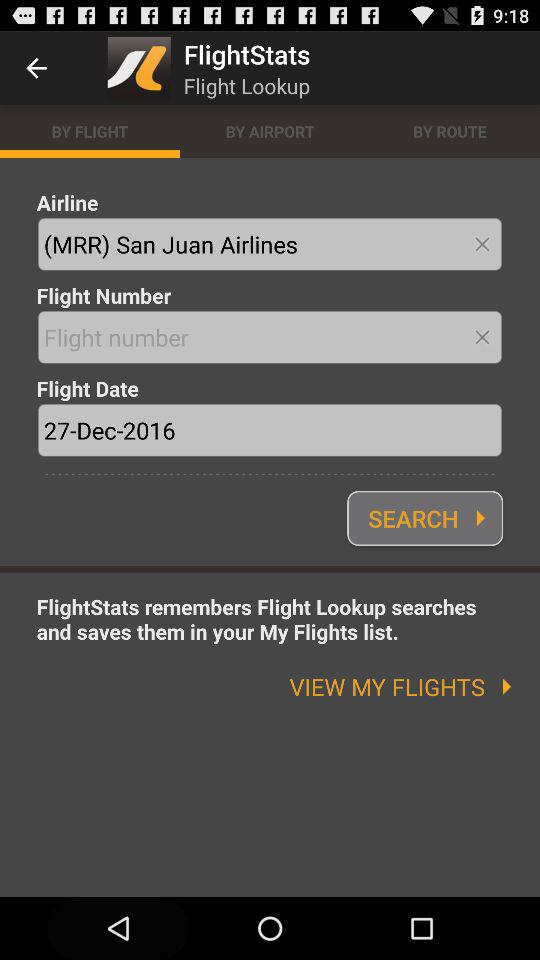What is the flight date? The flight date is December 27, 2016. 